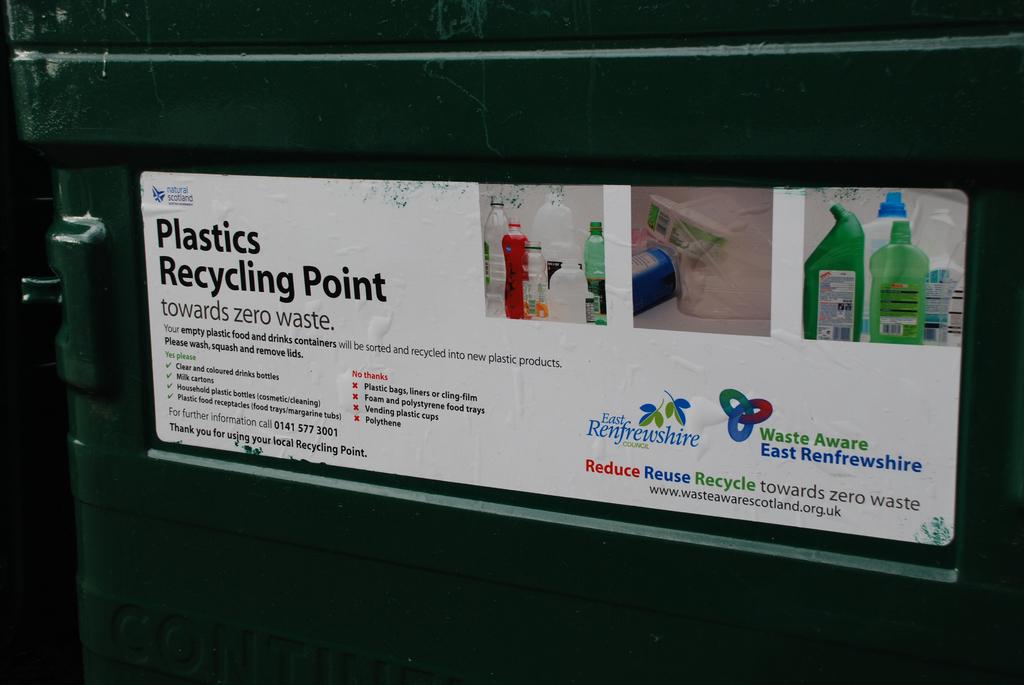What is this suppose to do?
Provide a succinct answer. Plastics recycling point. 